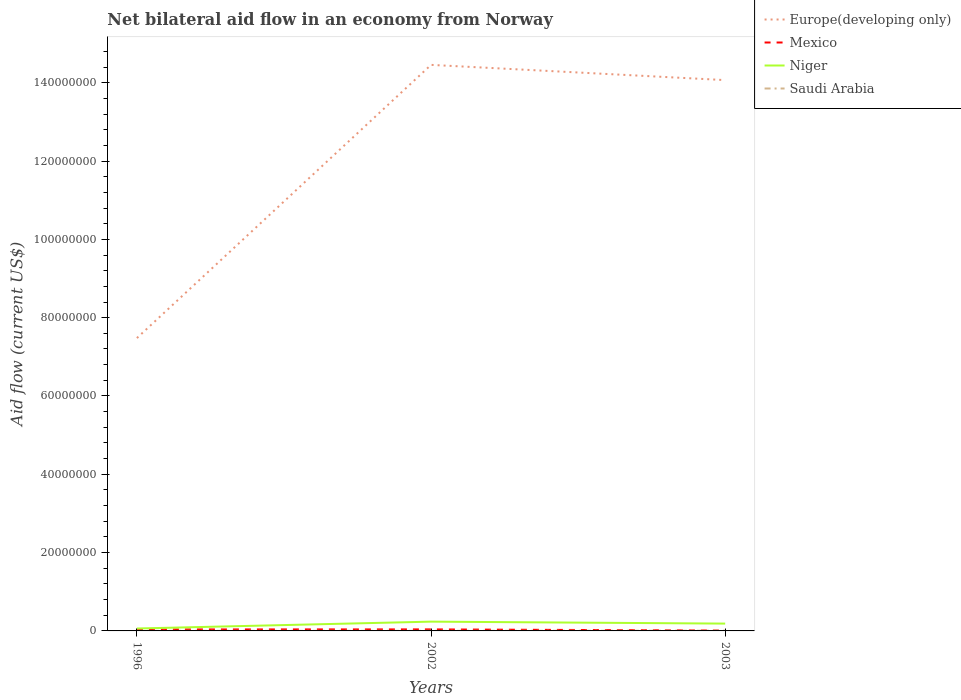Does the line corresponding to Mexico intersect with the line corresponding to Niger?
Offer a very short reply. No. Is the number of lines equal to the number of legend labels?
Keep it short and to the point. Yes. Across all years, what is the maximum net bilateral aid flow in Niger?
Ensure brevity in your answer.  6.20e+05. In which year was the net bilateral aid flow in Saudi Arabia maximum?
Your answer should be compact. 1996. What is the total net bilateral aid flow in Mexico in the graph?
Your answer should be very brief. -10000. What is the difference between the highest and the second highest net bilateral aid flow in Mexico?
Keep it short and to the point. 3.00e+05. What is the difference between the highest and the lowest net bilateral aid flow in Niger?
Offer a very short reply. 2. Is the net bilateral aid flow in Saudi Arabia strictly greater than the net bilateral aid flow in Europe(developing only) over the years?
Your response must be concise. Yes. Are the values on the major ticks of Y-axis written in scientific E-notation?
Ensure brevity in your answer.  No. Does the graph contain any zero values?
Give a very brief answer. No. Does the graph contain grids?
Offer a very short reply. No. Where does the legend appear in the graph?
Offer a very short reply. Top right. How are the legend labels stacked?
Give a very brief answer. Vertical. What is the title of the graph?
Your response must be concise. Net bilateral aid flow in an economy from Norway. What is the Aid flow (current US$) in Europe(developing only) in 1996?
Keep it short and to the point. 7.48e+07. What is the Aid flow (current US$) in Mexico in 1996?
Make the answer very short. 3.80e+05. What is the Aid flow (current US$) of Niger in 1996?
Provide a short and direct response. 6.20e+05. What is the Aid flow (current US$) of Saudi Arabia in 1996?
Ensure brevity in your answer.  2.00e+04. What is the Aid flow (current US$) of Europe(developing only) in 2002?
Provide a succinct answer. 1.45e+08. What is the Aid flow (current US$) of Mexico in 2002?
Make the answer very short. 3.90e+05. What is the Aid flow (current US$) of Niger in 2002?
Keep it short and to the point. 2.37e+06. What is the Aid flow (current US$) of Europe(developing only) in 2003?
Provide a short and direct response. 1.41e+08. What is the Aid flow (current US$) in Mexico in 2003?
Your answer should be compact. 9.00e+04. What is the Aid flow (current US$) in Niger in 2003?
Ensure brevity in your answer.  1.87e+06. What is the Aid flow (current US$) in Saudi Arabia in 2003?
Keep it short and to the point. 5.00e+04. Across all years, what is the maximum Aid flow (current US$) in Europe(developing only)?
Your answer should be very brief. 1.45e+08. Across all years, what is the maximum Aid flow (current US$) of Mexico?
Make the answer very short. 3.90e+05. Across all years, what is the maximum Aid flow (current US$) in Niger?
Offer a very short reply. 2.37e+06. Across all years, what is the minimum Aid flow (current US$) in Europe(developing only)?
Ensure brevity in your answer.  7.48e+07. Across all years, what is the minimum Aid flow (current US$) in Niger?
Keep it short and to the point. 6.20e+05. Across all years, what is the minimum Aid flow (current US$) in Saudi Arabia?
Provide a succinct answer. 2.00e+04. What is the total Aid flow (current US$) of Europe(developing only) in the graph?
Offer a terse response. 3.60e+08. What is the total Aid flow (current US$) in Mexico in the graph?
Give a very brief answer. 8.60e+05. What is the total Aid flow (current US$) of Niger in the graph?
Provide a succinct answer. 4.86e+06. What is the total Aid flow (current US$) in Saudi Arabia in the graph?
Keep it short and to the point. 9.00e+04. What is the difference between the Aid flow (current US$) in Europe(developing only) in 1996 and that in 2002?
Offer a very short reply. -6.98e+07. What is the difference between the Aid flow (current US$) in Mexico in 1996 and that in 2002?
Keep it short and to the point. -10000. What is the difference between the Aid flow (current US$) of Niger in 1996 and that in 2002?
Offer a terse response. -1.75e+06. What is the difference between the Aid flow (current US$) of Europe(developing only) in 1996 and that in 2003?
Provide a short and direct response. -6.59e+07. What is the difference between the Aid flow (current US$) of Niger in 1996 and that in 2003?
Offer a very short reply. -1.25e+06. What is the difference between the Aid flow (current US$) in Saudi Arabia in 1996 and that in 2003?
Keep it short and to the point. -3.00e+04. What is the difference between the Aid flow (current US$) in Europe(developing only) in 2002 and that in 2003?
Your answer should be very brief. 3.89e+06. What is the difference between the Aid flow (current US$) of Mexico in 2002 and that in 2003?
Offer a terse response. 3.00e+05. What is the difference between the Aid flow (current US$) in Saudi Arabia in 2002 and that in 2003?
Keep it short and to the point. -3.00e+04. What is the difference between the Aid flow (current US$) in Europe(developing only) in 1996 and the Aid flow (current US$) in Mexico in 2002?
Keep it short and to the point. 7.44e+07. What is the difference between the Aid flow (current US$) of Europe(developing only) in 1996 and the Aid flow (current US$) of Niger in 2002?
Keep it short and to the point. 7.24e+07. What is the difference between the Aid flow (current US$) of Europe(developing only) in 1996 and the Aid flow (current US$) of Saudi Arabia in 2002?
Provide a short and direct response. 7.48e+07. What is the difference between the Aid flow (current US$) of Mexico in 1996 and the Aid flow (current US$) of Niger in 2002?
Ensure brevity in your answer.  -1.99e+06. What is the difference between the Aid flow (current US$) in Europe(developing only) in 1996 and the Aid flow (current US$) in Mexico in 2003?
Ensure brevity in your answer.  7.47e+07. What is the difference between the Aid flow (current US$) in Europe(developing only) in 1996 and the Aid flow (current US$) in Niger in 2003?
Provide a short and direct response. 7.29e+07. What is the difference between the Aid flow (current US$) of Europe(developing only) in 1996 and the Aid flow (current US$) of Saudi Arabia in 2003?
Make the answer very short. 7.47e+07. What is the difference between the Aid flow (current US$) of Mexico in 1996 and the Aid flow (current US$) of Niger in 2003?
Ensure brevity in your answer.  -1.49e+06. What is the difference between the Aid flow (current US$) in Mexico in 1996 and the Aid flow (current US$) in Saudi Arabia in 2003?
Provide a succinct answer. 3.30e+05. What is the difference between the Aid flow (current US$) of Niger in 1996 and the Aid flow (current US$) of Saudi Arabia in 2003?
Ensure brevity in your answer.  5.70e+05. What is the difference between the Aid flow (current US$) of Europe(developing only) in 2002 and the Aid flow (current US$) of Mexico in 2003?
Your answer should be very brief. 1.44e+08. What is the difference between the Aid flow (current US$) of Europe(developing only) in 2002 and the Aid flow (current US$) of Niger in 2003?
Your answer should be compact. 1.43e+08. What is the difference between the Aid flow (current US$) of Europe(developing only) in 2002 and the Aid flow (current US$) of Saudi Arabia in 2003?
Give a very brief answer. 1.45e+08. What is the difference between the Aid flow (current US$) of Mexico in 2002 and the Aid flow (current US$) of Niger in 2003?
Provide a succinct answer. -1.48e+06. What is the difference between the Aid flow (current US$) of Mexico in 2002 and the Aid flow (current US$) of Saudi Arabia in 2003?
Offer a terse response. 3.40e+05. What is the difference between the Aid flow (current US$) of Niger in 2002 and the Aid flow (current US$) of Saudi Arabia in 2003?
Your answer should be compact. 2.32e+06. What is the average Aid flow (current US$) of Europe(developing only) per year?
Your answer should be compact. 1.20e+08. What is the average Aid flow (current US$) of Mexico per year?
Provide a succinct answer. 2.87e+05. What is the average Aid flow (current US$) in Niger per year?
Provide a short and direct response. 1.62e+06. In the year 1996, what is the difference between the Aid flow (current US$) in Europe(developing only) and Aid flow (current US$) in Mexico?
Provide a short and direct response. 7.44e+07. In the year 1996, what is the difference between the Aid flow (current US$) of Europe(developing only) and Aid flow (current US$) of Niger?
Ensure brevity in your answer.  7.42e+07. In the year 1996, what is the difference between the Aid flow (current US$) of Europe(developing only) and Aid flow (current US$) of Saudi Arabia?
Your response must be concise. 7.48e+07. In the year 2002, what is the difference between the Aid flow (current US$) in Europe(developing only) and Aid flow (current US$) in Mexico?
Your answer should be compact. 1.44e+08. In the year 2002, what is the difference between the Aid flow (current US$) in Europe(developing only) and Aid flow (current US$) in Niger?
Your answer should be compact. 1.42e+08. In the year 2002, what is the difference between the Aid flow (current US$) in Europe(developing only) and Aid flow (current US$) in Saudi Arabia?
Ensure brevity in your answer.  1.45e+08. In the year 2002, what is the difference between the Aid flow (current US$) in Mexico and Aid flow (current US$) in Niger?
Provide a succinct answer. -1.98e+06. In the year 2002, what is the difference between the Aid flow (current US$) of Mexico and Aid flow (current US$) of Saudi Arabia?
Provide a succinct answer. 3.70e+05. In the year 2002, what is the difference between the Aid flow (current US$) in Niger and Aid flow (current US$) in Saudi Arabia?
Keep it short and to the point. 2.35e+06. In the year 2003, what is the difference between the Aid flow (current US$) in Europe(developing only) and Aid flow (current US$) in Mexico?
Give a very brief answer. 1.41e+08. In the year 2003, what is the difference between the Aid flow (current US$) of Europe(developing only) and Aid flow (current US$) of Niger?
Provide a succinct answer. 1.39e+08. In the year 2003, what is the difference between the Aid flow (current US$) in Europe(developing only) and Aid flow (current US$) in Saudi Arabia?
Your answer should be compact. 1.41e+08. In the year 2003, what is the difference between the Aid flow (current US$) of Mexico and Aid flow (current US$) of Niger?
Ensure brevity in your answer.  -1.78e+06. In the year 2003, what is the difference between the Aid flow (current US$) of Niger and Aid flow (current US$) of Saudi Arabia?
Give a very brief answer. 1.82e+06. What is the ratio of the Aid flow (current US$) in Europe(developing only) in 1996 to that in 2002?
Give a very brief answer. 0.52. What is the ratio of the Aid flow (current US$) of Mexico in 1996 to that in 2002?
Your answer should be very brief. 0.97. What is the ratio of the Aid flow (current US$) in Niger in 1996 to that in 2002?
Your answer should be very brief. 0.26. What is the ratio of the Aid flow (current US$) of Europe(developing only) in 1996 to that in 2003?
Your answer should be compact. 0.53. What is the ratio of the Aid flow (current US$) in Mexico in 1996 to that in 2003?
Keep it short and to the point. 4.22. What is the ratio of the Aid flow (current US$) in Niger in 1996 to that in 2003?
Ensure brevity in your answer.  0.33. What is the ratio of the Aid flow (current US$) of Saudi Arabia in 1996 to that in 2003?
Your answer should be very brief. 0.4. What is the ratio of the Aid flow (current US$) of Europe(developing only) in 2002 to that in 2003?
Ensure brevity in your answer.  1.03. What is the ratio of the Aid flow (current US$) of Mexico in 2002 to that in 2003?
Offer a very short reply. 4.33. What is the ratio of the Aid flow (current US$) in Niger in 2002 to that in 2003?
Ensure brevity in your answer.  1.27. What is the difference between the highest and the second highest Aid flow (current US$) of Europe(developing only)?
Offer a terse response. 3.89e+06. What is the difference between the highest and the second highest Aid flow (current US$) of Mexico?
Your answer should be very brief. 10000. What is the difference between the highest and the lowest Aid flow (current US$) of Europe(developing only)?
Offer a very short reply. 6.98e+07. What is the difference between the highest and the lowest Aid flow (current US$) in Mexico?
Your response must be concise. 3.00e+05. What is the difference between the highest and the lowest Aid flow (current US$) in Niger?
Give a very brief answer. 1.75e+06. 